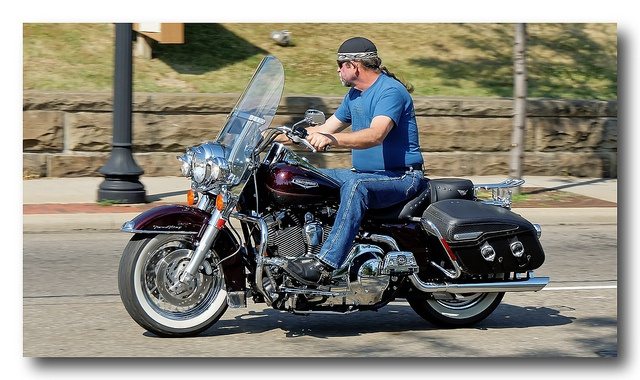Describe the objects in this image and their specific colors. I can see motorcycle in white, black, gray, darkgray, and lightgray tones and people in white, gray, black, navy, and lightblue tones in this image. 